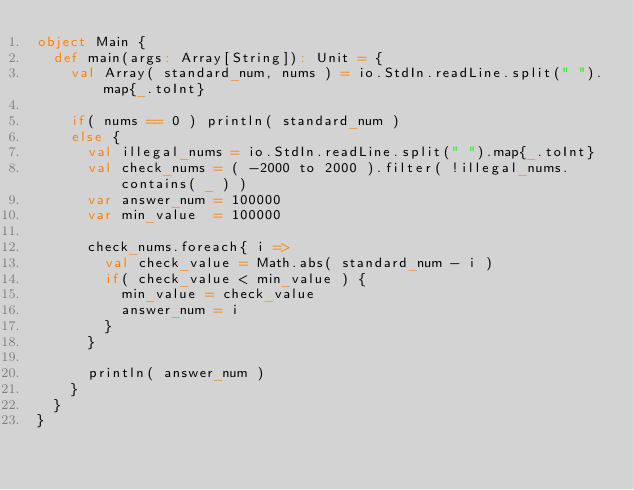Convert code to text. <code><loc_0><loc_0><loc_500><loc_500><_Scala_>object Main {
  def main(args: Array[String]): Unit = {
    val Array( standard_num, nums ) = io.StdIn.readLine.split(" ").map{_.toInt}

    if( nums == 0 ) println( standard_num )
    else {
      val illegal_nums = io.StdIn.readLine.split(" ").map{_.toInt}
      val check_nums = ( -2000 to 2000 ).filter( !illegal_nums.contains( _ ) )
      var answer_num = 100000
      var min_value  = 100000

      check_nums.foreach{ i =>
        val check_value = Math.abs( standard_num - i )
        if( check_value < min_value ) {
          min_value = check_value
          answer_num = i
        }
      }

      println( answer_num )
    }
  }
}</code> 